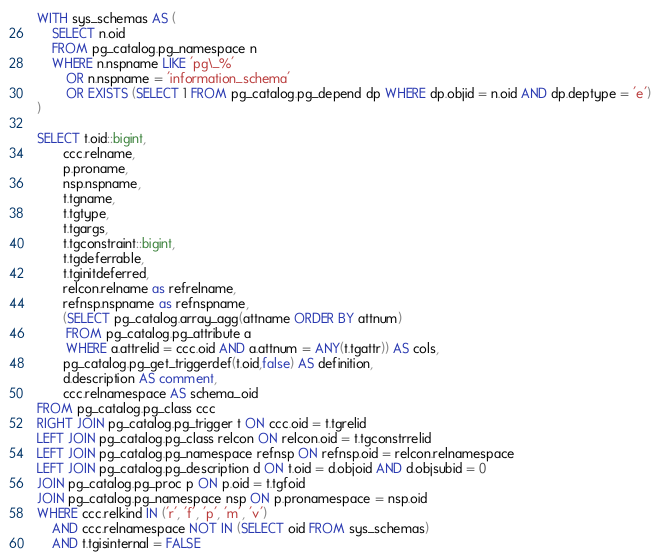Convert code to text. <code><loc_0><loc_0><loc_500><loc_500><_SQL_>WITH sys_schemas AS (
    SELECT n.oid
    FROM pg_catalog.pg_namespace n
    WHERE n.nspname LIKE 'pg\_%'
        OR n.nspname = 'information_schema'
        OR EXISTS (SELECT 1 FROM pg_catalog.pg_depend dp WHERE dp.objid = n.oid AND dp.deptype = 'e')
)

SELECT t.oid::bigint,
       ccc.relname,
       p.proname,
       nsp.nspname,
       t.tgname,
       t.tgtype,
       t.tgargs,
       t.tgconstraint::bigint,
       t.tgdeferrable,
       t.tginitdeferred,
       relcon.relname as refrelname,
       refnsp.nspname as refnspname,
       (SELECT pg_catalog.array_agg(attname ORDER BY attnum) 
        FROM pg_catalog.pg_attribute a
        WHERE a.attrelid = ccc.oid AND a.attnum = ANY(t.tgattr)) AS cols,
       pg_catalog.pg_get_triggerdef(t.oid,false) AS definition,
       d.description AS comment,
       ccc.relnamespace AS schema_oid
FROM pg_catalog.pg_class ccc
RIGHT JOIN pg_catalog.pg_trigger t ON ccc.oid = t.tgrelid
LEFT JOIN pg_catalog.pg_class relcon ON relcon.oid = t.tgconstrrelid
LEFT JOIN pg_catalog.pg_namespace refnsp ON refnsp.oid = relcon.relnamespace
LEFT JOIN pg_catalog.pg_description d ON t.oid = d.objoid AND d.objsubid = 0
JOIN pg_catalog.pg_proc p ON p.oid = t.tgfoid
JOIN pg_catalog.pg_namespace nsp ON p.pronamespace = nsp.oid
WHERE ccc.relkind IN ('r', 'f', 'p', 'm', 'v')
    AND ccc.relnamespace NOT IN (SELECT oid FROM sys_schemas)
    AND t.tgisinternal = FALSE</code> 